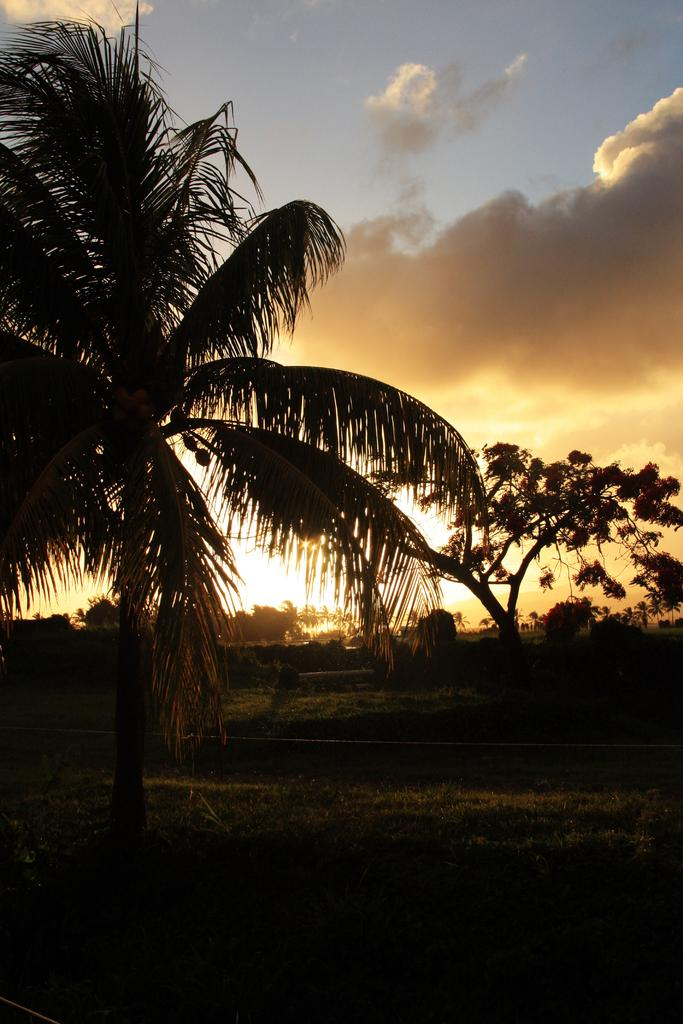What type of vegetation can be seen in the image? There are trees in the image. What is at the bottom of the image? There is grass at the bottom of the image. What is visible at the top of the image? The sky is visible at the top of the image. What can be seen in the sky? There are clouds in the sky. What type of toys are scattered on the grass in the image? There are no toys present in the image; it features trees, grass, and clouds in the sky. What is the temper of the clouds in the image? The image does not depict the temper of the clouds; it simply shows their presence in the sky. 